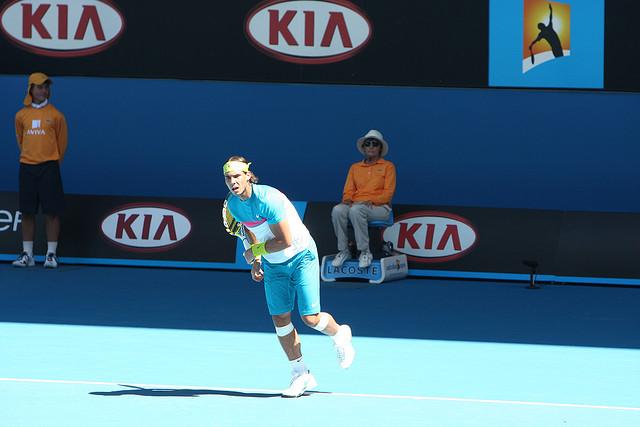What is the lady on the chair doing?
Short answer required. Sitting. Is the person running?
Concise answer only. Yes. What is the name of the sponsor on the chair?
Answer briefly. Lacoste. 